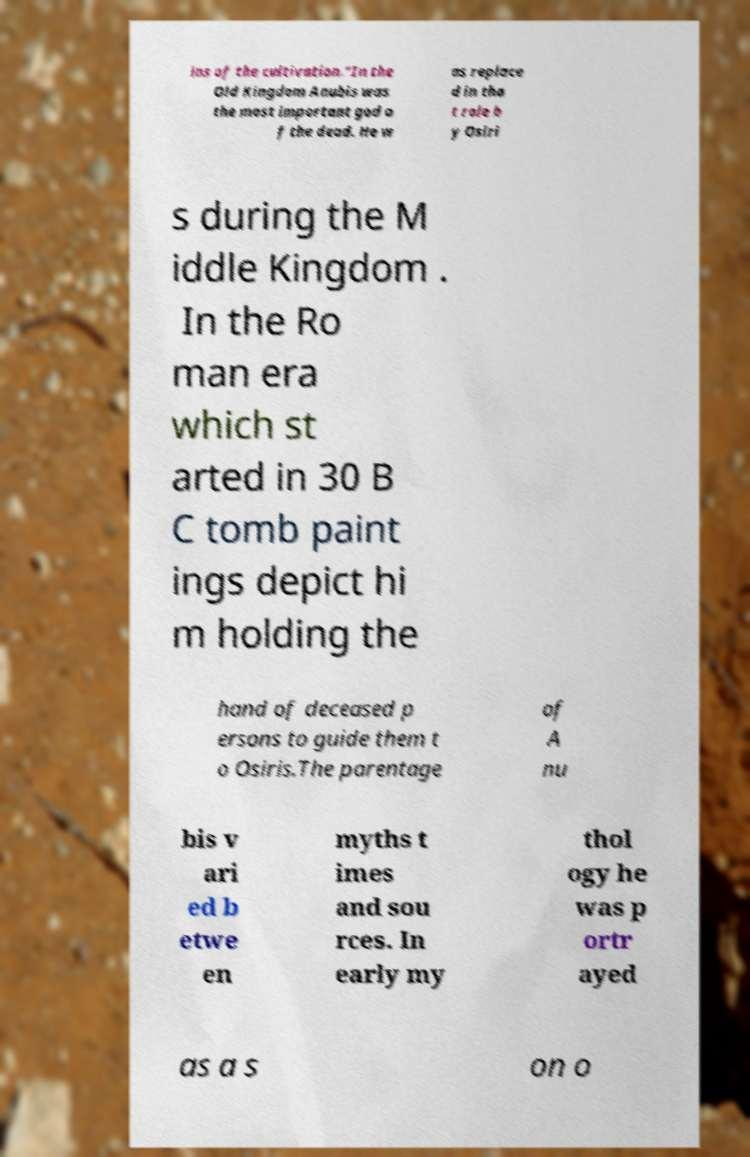There's text embedded in this image that I need extracted. Can you transcribe it verbatim? ins of the cultivation."In the Old Kingdom Anubis was the most important god o f the dead. He w as replace d in tha t role b y Osiri s during the M iddle Kingdom . In the Ro man era which st arted in 30 B C tomb paint ings depict hi m holding the hand of deceased p ersons to guide them t o Osiris.The parentage of A nu bis v ari ed b etwe en myths t imes and sou rces. In early my thol ogy he was p ortr ayed as a s on o 